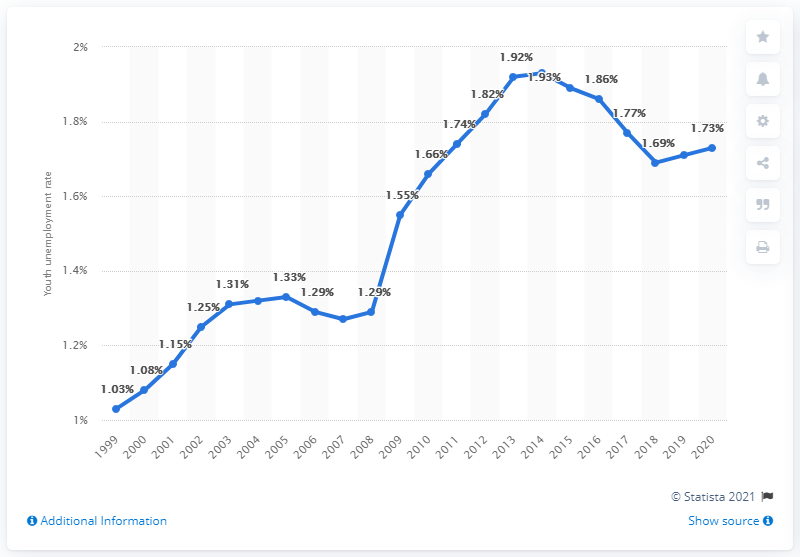Point out several critical features in this image. In 2020, the youth unemployment rate in Rwanda was 1.73%. 